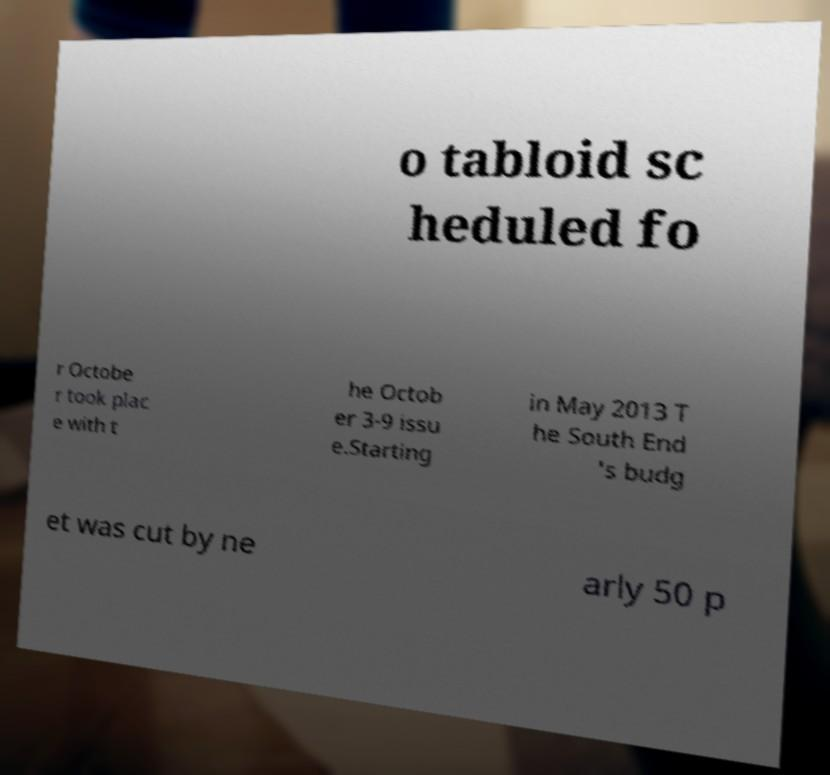There's text embedded in this image that I need extracted. Can you transcribe it verbatim? o tabloid sc heduled fo r Octobe r took plac e with t he Octob er 3-9 issu e.Starting in May 2013 T he South End 's budg et was cut by ne arly 50 p 